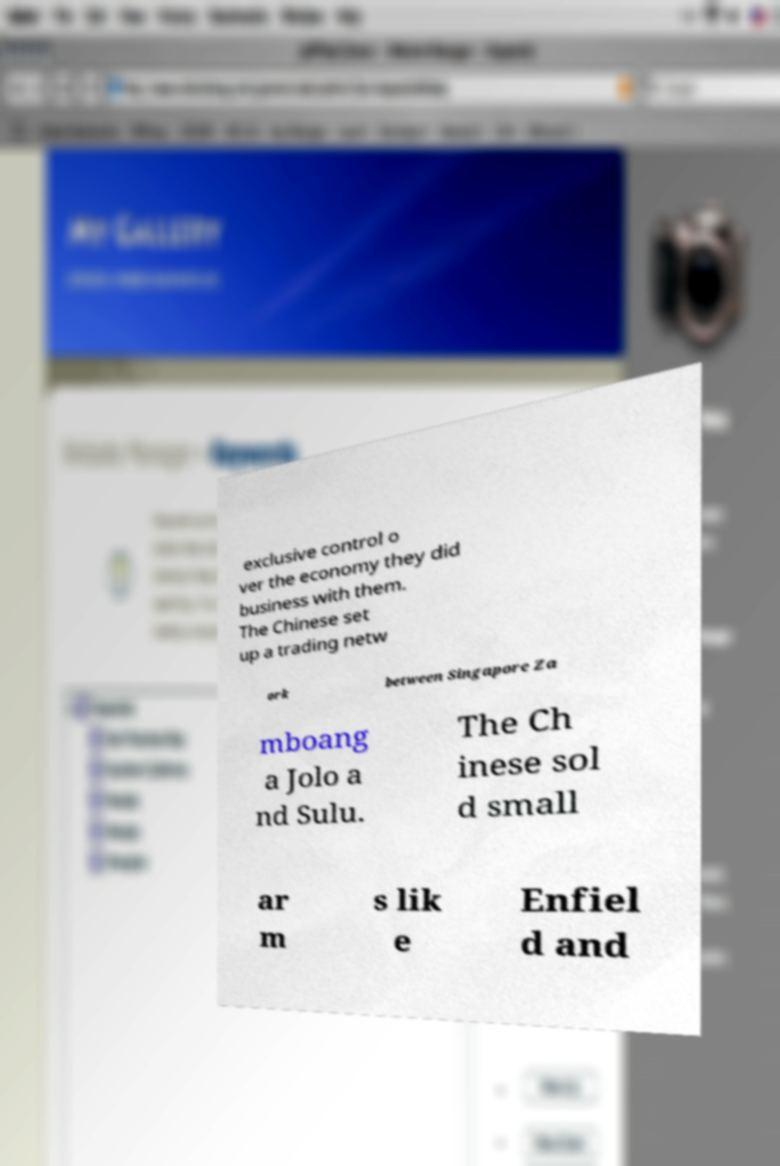Can you read and provide the text displayed in the image?This photo seems to have some interesting text. Can you extract and type it out for me? exclusive control o ver the economy they did business with them. The Chinese set up a trading netw ork between Singapore Za mboang a Jolo a nd Sulu. The Ch inese sol d small ar m s lik e Enfiel d and 